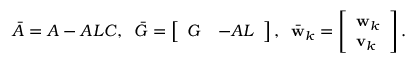<formula> <loc_0><loc_0><loc_500><loc_500>\begin{array} { r } { \bar { A } = A - A L C , \, \bar { G } = \left [ \begin{array} { l l } { G } & { - A L } \end{array} \right ] , \, \bar { w } _ { k } = \left [ \begin{array} { l } { w _ { k } } \\ { v _ { k } } \end{array} \right ] . } \end{array}</formula> 